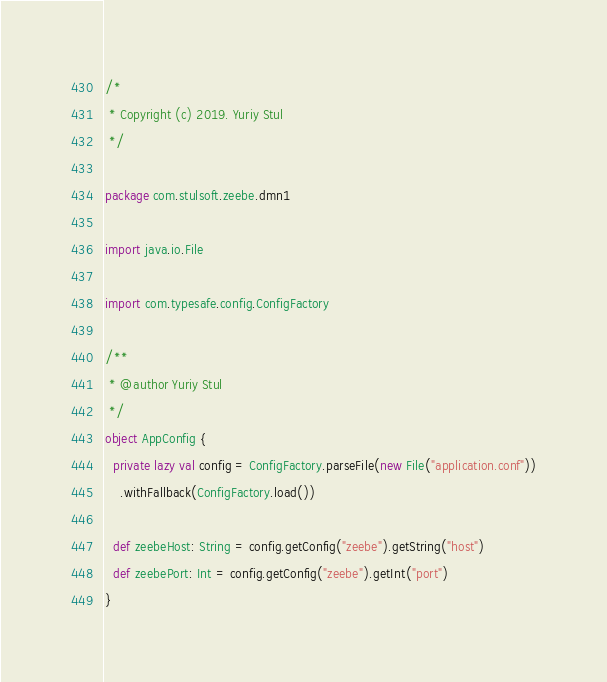Convert code to text. <code><loc_0><loc_0><loc_500><loc_500><_Scala_>/*
 * Copyright (c) 2019. Yuriy Stul
 */

package com.stulsoft.zeebe.dmn1

import java.io.File

import com.typesafe.config.ConfigFactory

/**
 * @author Yuriy Stul
 */
object AppConfig {
  private lazy val config = ConfigFactory.parseFile(new File("application.conf"))
    .withFallback(ConfigFactory.load())

  def zeebeHost: String = config.getConfig("zeebe").getString("host")
  def zeebePort: Int = config.getConfig("zeebe").getInt("port")
}
</code> 